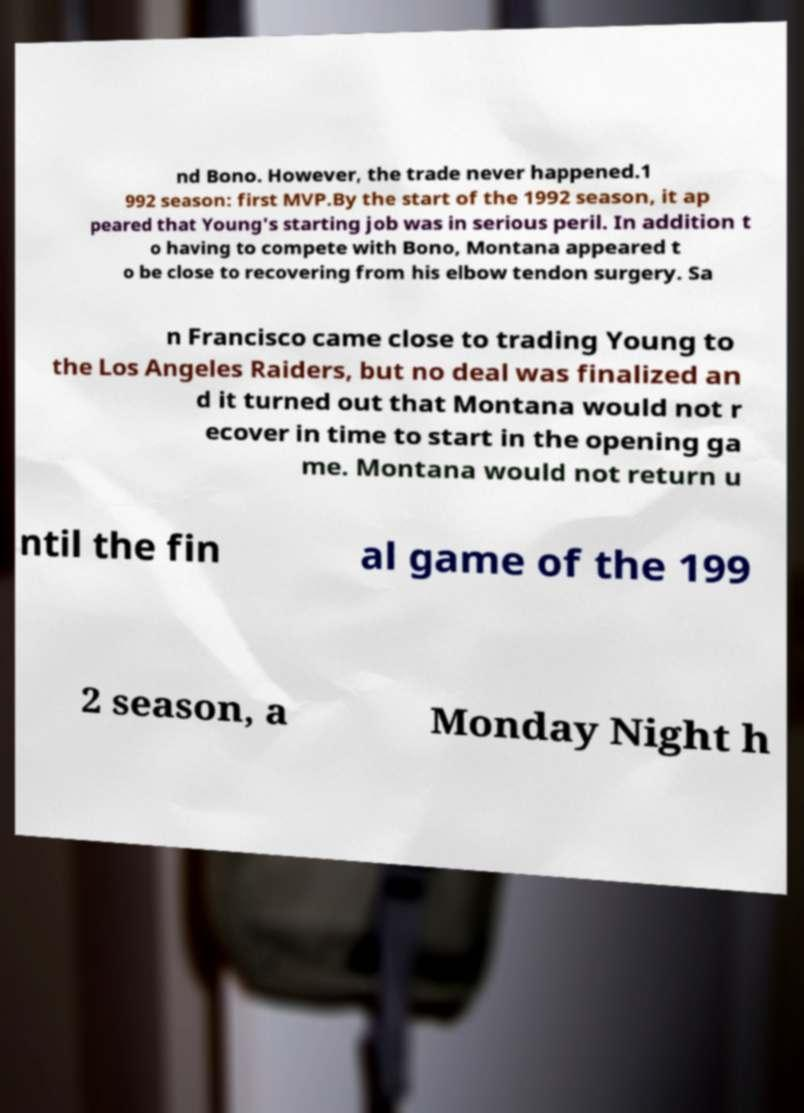What messages or text are displayed in this image? I need them in a readable, typed format. nd Bono. However, the trade never happened.1 992 season: first MVP.By the start of the 1992 season, it ap peared that Young's starting job was in serious peril. In addition t o having to compete with Bono, Montana appeared t o be close to recovering from his elbow tendon surgery. Sa n Francisco came close to trading Young to the Los Angeles Raiders, but no deal was finalized an d it turned out that Montana would not r ecover in time to start in the opening ga me. Montana would not return u ntil the fin al game of the 199 2 season, a Monday Night h 